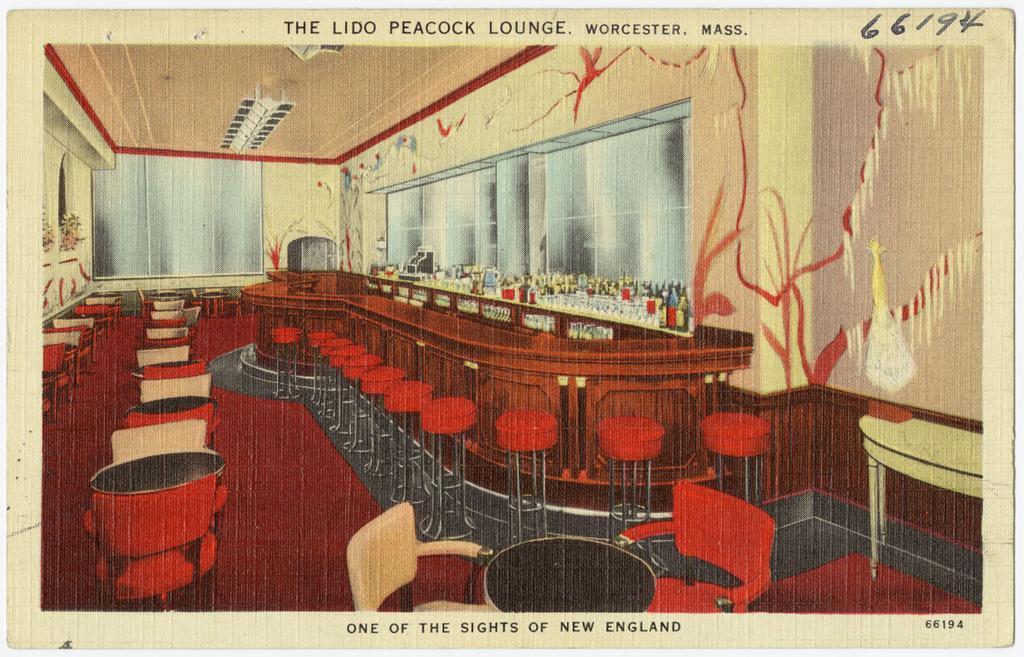In one or two sentences, can you explain what this image depicts? In this picture, it seems like a poster and text. 